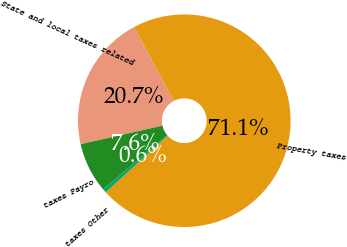Convert chart. <chart><loc_0><loc_0><loc_500><loc_500><pie_chart><fcel>Property taxes<fcel>State and local taxes related<fcel>taxes Payro<fcel>taxes Other<nl><fcel>71.1%<fcel>20.7%<fcel>7.63%<fcel>0.57%<nl></chart> 